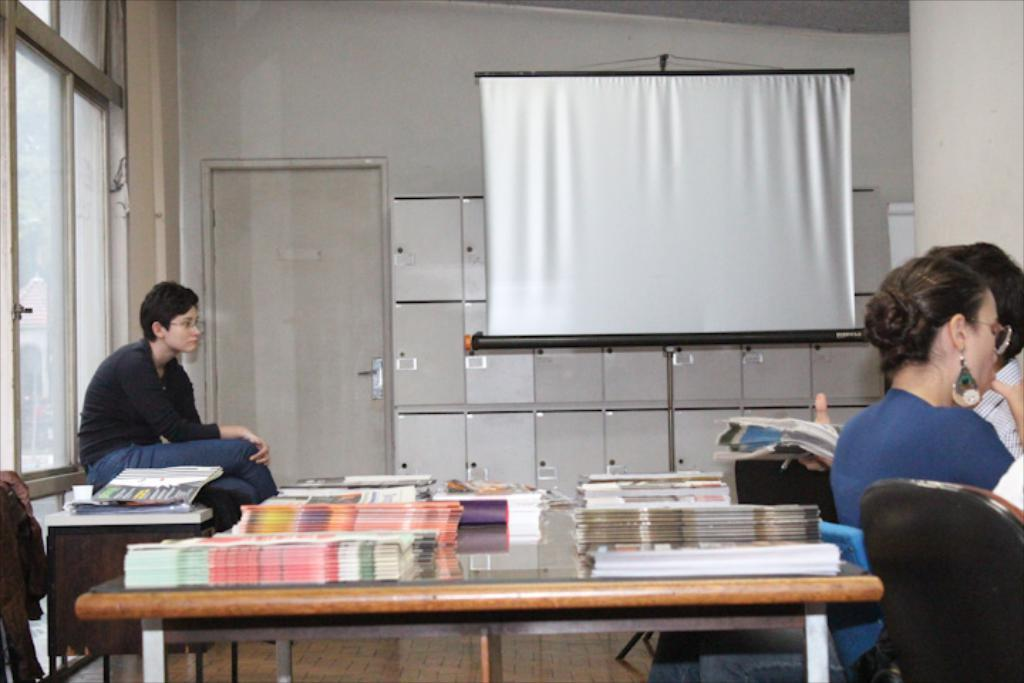What are the people in the image doing? The people in the image are sitting. What is on the table in the image? There are papers on the table. What furniture is present in the image? There are chairs and a table in the image. What architectural feature can be seen in the image? There is a door in the image. What is used for displaying visual information in the image? There is a projector's screen in the image. Is there any quicksand present in the image? No, there is no quicksand present in the image. Can you identify any lawyers in the image? There is no information about the profession of the people in the image, so we cannot determine if there are any lawyers present. 